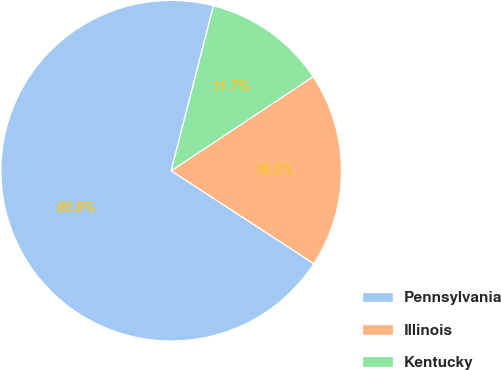<chart> <loc_0><loc_0><loc_500><loc_500><pie_chart><fcel>Pennsylvania<fcel>Illinois<fcel>Kentucky<nl><fcel>69.8%<fcel>18.51%<fcel>11.69%<nl></chart> 